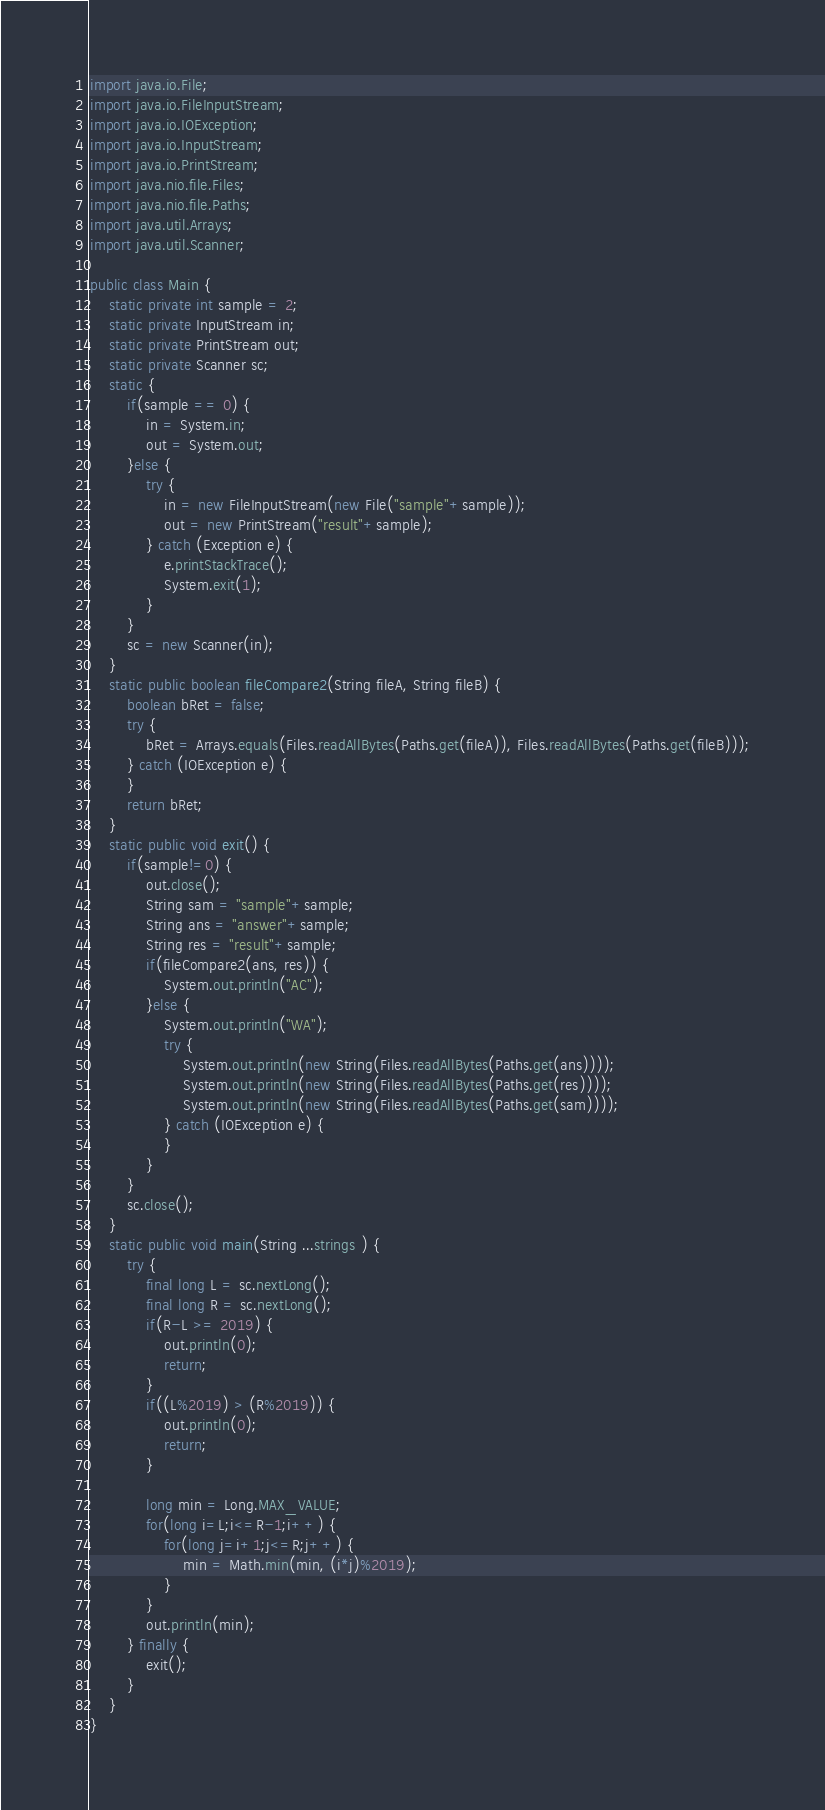<code> <loc_0><loc_0><loc_500><loc_500><_Java_>import java.io.File;
import java.io.FileInputStream;
import java.io.IOException;
import java.io.InputStream;
import java.io.PrintStream;
import java.nio.file.Files;
import java.nio.file.Paths;
import java.util.Arrays;
import java.util.Scanner;

public class Main {
	static private int sample = 2;
	static private InputStream in;
	static private PrintStream out;
	static private Scanner sc;
	static {
		if(sample == 0) {
			in = System.in;
			out = System.out;
		}else {
			try {
				in = new FileInputStream(new File("sample"+sample));
				out = new PrintStream("result"+sample);
			} catch (Exception e) {
				e.printStackTrace();
				System.exit(1);
			}
		}
		sc = new Scanner(in);
	}
	static public boolean fileCompare2(String fileA, String fileB) {
		boolean bRet = false;
		try {
			bRet = Arrays.equals(Files.readAllBytes(Paths.get(fileA)), Files.readAllBytes(Paths.get(fileB)));
		} catch (IOException e) {
		}
		return bRet;
	}
	static public void exit() {
		if(sample!=0) {
			out.close();
			String sam = "sample"+sample;
			String ans = "answer"+sample;
			String res = "result"+sample;
			if(fileCompare2(ans, res)) {
				System.out.println("AC");
			}else {
				System.out.println("WA");
				try {
					System.out.println(new String(Files.readAllBytes(Paths.get(ans))));
					System.out.println(new String(Files.readAllBytes(Paths.get(res))));
					System.out.println(new String(Files.readAllBytes(Paths.get(sam))));
				} catch (IOException e) {
				}
			}
		}
		sc.close();
	}
	static public void main(String ...strings ) {
		try {
			final long L = sc.nextLong();
			final long R = sc.nextLong();
			if(R-L >= 2019) {
				out.println(0);
				return;
			}
			if((L%2019) > (R%2019)) {
				out.println(0);
				return;
			}

			long min = Long.MAX_VALUE;
			for(long i=L;i<=R-1;i++) {
				for(long j=i+1;j<=R;j++) {
					min = Math.min(min, (i*j)%2019);
				}
			}
			out.println(min);
		} finally {
			exit();
		}
	}
}
</code> 